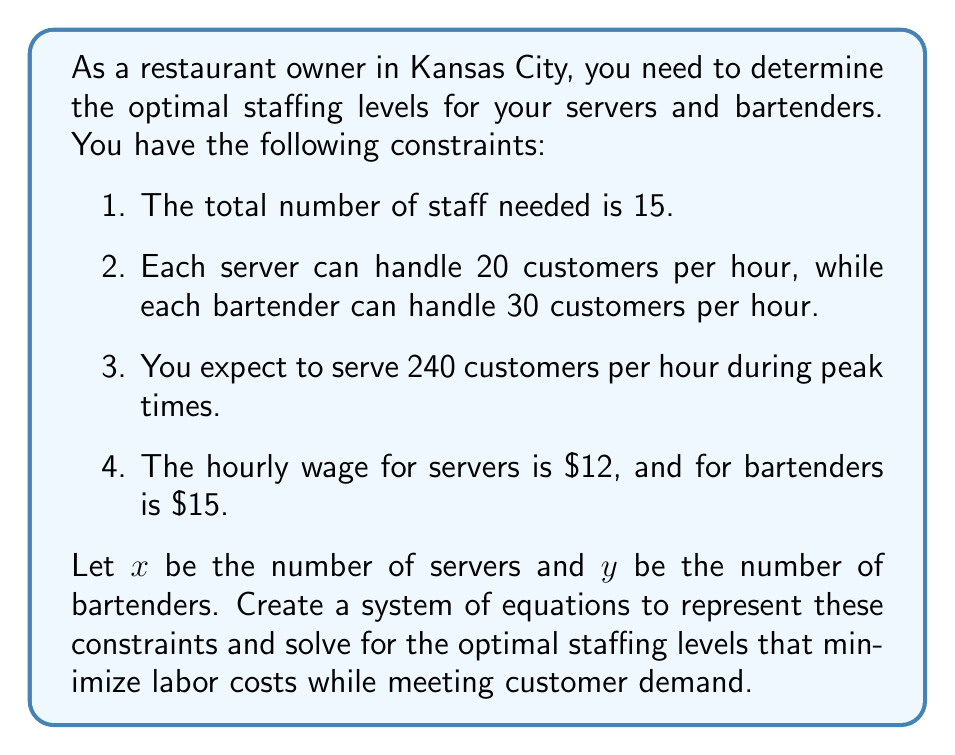Give your solution to this math problem. Let's approach this step-by-step:

1. First, we need to set up our system of equations based on the given constraints:

   a. Total staff: $x + y = 15$
   b. Customer capacity: $20x + 30y = 240$

2. We now have a system of two equations with two unknowns:

   $$\begin{cases}
   x + y = 15 \\
   20x + 30y = 240
   \end{cases}$$

3. Let's solve this system using substitution. From the first equation:
   $y = 15 - x$

4. Substitute this into the second equation:
   $20x + 30(15 - x) = 240$

5. Simplify:
   $20x + 450 - 30x = 240$
   $-10x + 450 = 240$
   $-10x = -210$
   $x = 21$

6. Now substitute this value of $x$ back into $y = 15 - x$:
   $y = 15 - 21 = -6$

7. However, we can't have negative staff members. This means our initial assumption that we need exactly 15 staff members to minimize costs while meeting demand is incorrect.

8. Let's recalculate using the customer capacity equation:
   $20x + 30y = 240$

   If we use 12 servers $(x = 12)$, then:
   $20(12) + 30y = 240$
   $240 + 30y = 240$
   $30y = 0$
   $y = 0$

9. This solution meets our constraints: 12 servers can handle 240 customers per hour, and we don't need any bartenders.

10. To calculate the hourly labor cost:
    $12 \text{ servers} \times \$12/\text{hour} = \$144/\text{hour}$

This staffing arrangement minimizes labor costs while meeting customer demand.
Answer: 12 servers, 0 bartenders; $144/hour 